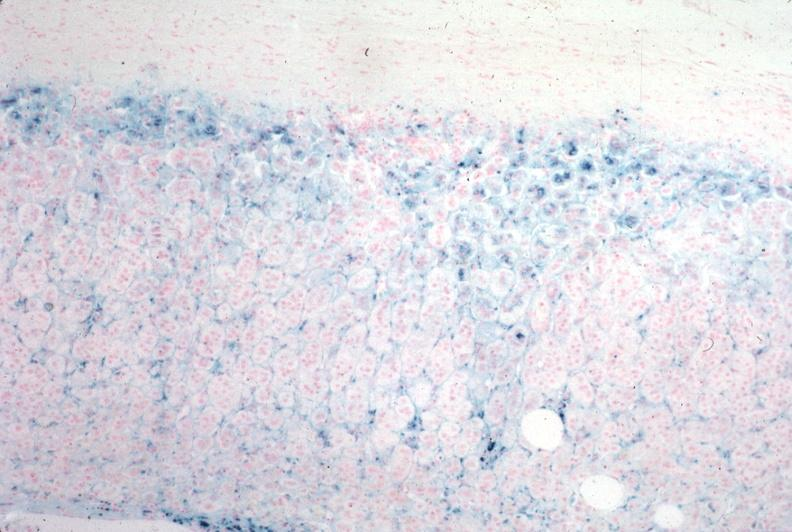what is present?
Answer the question using a single word or phrase. Endocrine 